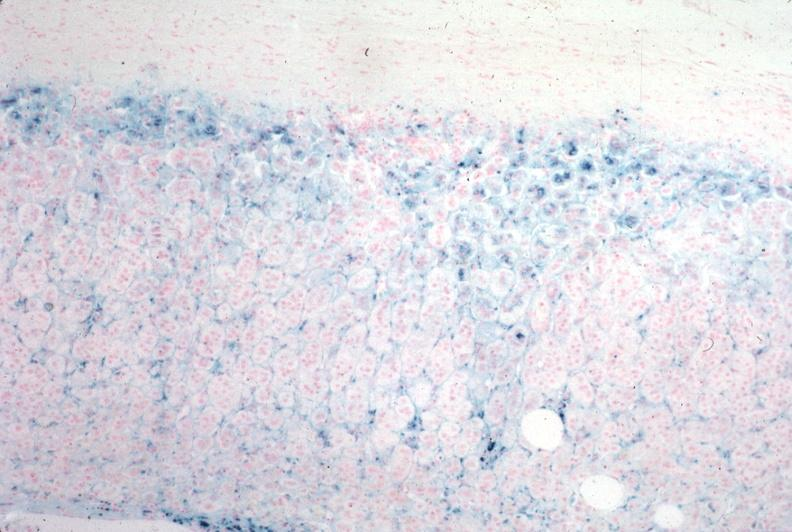what is present?
Answer the question using a single word or phrase. Endocrine 